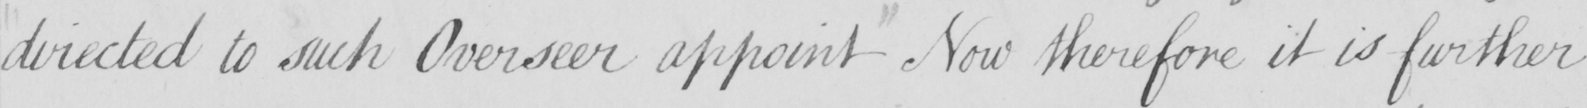Transcribe the text shown in this historical manuscript line. directed to such Overseer appoint Now therefore it is further 